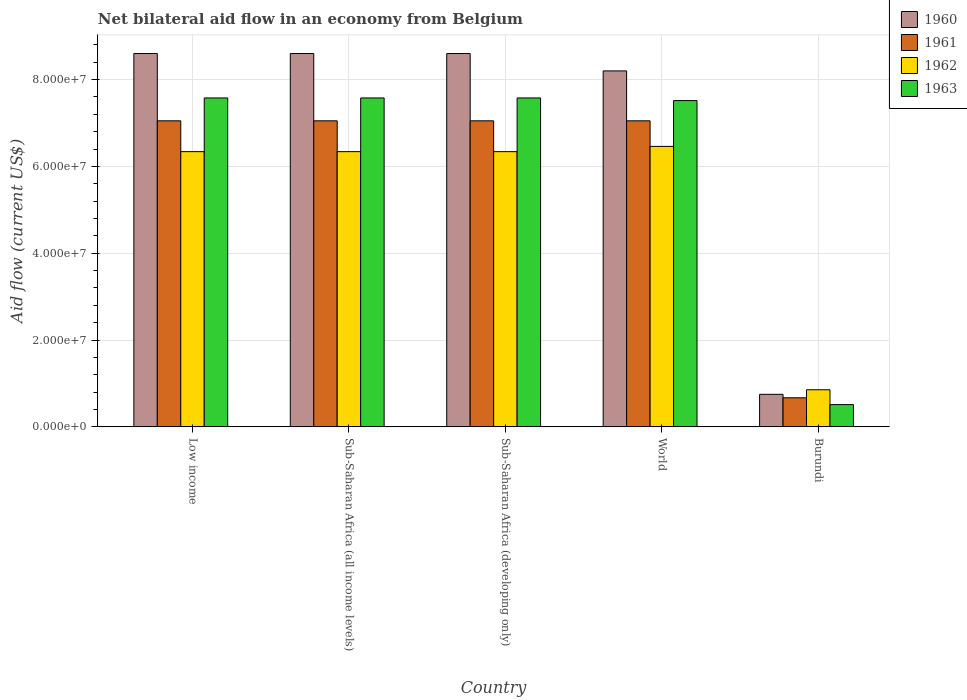How many groups of bars are there?
Keep it short and to the point. 5. Are the number of bars per tick equal to the number of legend labels?
Ensure brevity in your answer.  Yes. How many bars are there on the 1st tick from the left?
Provide a succinct answer. 4. What is the label of the 3rd group of bars from the left?
Your response must be concise. Sub-Saharan Africa (developing only). In how many cases, is the number of bars for a given country not equal to the number of legend labels?
Provide a short and direct response. 0. What is the net bilateral aid flow in 1962 in Burundi?
Offer a terse response. 8.55e+06. Across all countries, what is the maximum net bilateral aid flow in 1961?
Your response must be concise. 7.05e+07. Across all countries, what is the minimum net bilateral aid flow in 1961?
Your answer should be compact. 6.70e+06. In which country was the net bilateral aid flow in 1963 maximum?
Give a very brief answer. Low income. In which country was the net bilateral aid flow in 1960 minimum?
Your answer should be compact. Burundi. What is the total net bilateral aid flow in 1960 in the graph?
Make the answer very short. 3.48e+08. What is the difference between the net bilateral aid flow in 1960 in Sub-Saharan Africa (all income levels) and that in World?
Keep it short and to the point. 4.00e+06. What is the difference between the net bilateral aid flow in 1961 in Sub-Saharan Africa (all income levels) and the net bilateral aid flow in 1963 in World?
Your answer should be very brief. -4.66e+06. What is the average net bilateral aid flow in 1961 per country?
Ensure brevity in your answer.  5.77e+07. What is the difference between the net bilateral aid flow of/in 1962 and net bilateral aid flow of/in 1961 in Low income?
Give a very brief answer. -7.10e+06. In how many countries, is the net bilateral aid flow in 1962 greater than 24000000 US$?
Give a very brief answer. 4. What is the ratio of the net bilateral aid flow in 1960 in Low income to that in World?
Your response must be concise. 1.05. Is the net bilateral aid flow in 1962 in Burundi less than that in World?
Ensure brevity in your answer.  Yes. What is the difference between the highest and the second highest net bilateral aid flow in 1962?
Your answer should be very brief. 1.21e+06. What is the difference between the highest and the lowest net bilateral aid flow in 1961?
Your answer should be compact. 6.38e+07. In how many countries, is the net bilateral aid flow in 1962 greater than the average net bilateral aid flow in 1962 taken over all countries?
Your answer should be compact. 4. Is it the case that in every country, the sum of the net bilateral aid flow in 1960 and net bilateral aid flow in 1961 is greater than the sum of net bilateral aid flow in 1963 and net bilateral aid flow in 1962?
Keep it short and to the point. No. What does the 3rd bar from the left in Sub-Saharan Africa (developing only) represents?
Provide a short and direct response. 1962. Are all the bars in the graph horizontal?
Your answer should be very brief. No. How many countries are there in the graph?
Offer a very short reply. 5. Does the graph contain any zero values?
Provide a succinct answer. No. Does the graph contain grids?
Keep it short and to the point. Yes. How are the legend labels stacked?
Offer a very short reply. Vertical. What is the title of the graph?
Ensure brevity in your answer.  Net bilateral aid flow in an economy from Belgium. What is the label or title of the Y-axis?
Provide a short and direct response. Aid flow (current US$). What is the Aid flow (current US$) in 1960 in Low income?
Your answer should be compact. 8.60e+07. What is the Aid flow (current US$) of 1961 in Low income?
Your answer should be compact. 7.05e+07. What is the Aid flow (current US$) of 1962 in Low income?
Your answer should be very brief. 6.34e+07. What is the Aid flow (current US$) of 1963 in Low income?
Keep it short and to the point. 7.58e+07. What is the Aid flow (current US$) in 1960 in Sub-Saharan Africa (all income levels)?
Offer a very short reply. 8.60e+07. What is the Aid flow (current US$) in 1961 in Sub-Saharan Africa (all income levels)?
Ensure brevity in your answer.  7.05e+07. What is the Aid flow (current US$) of 1962 in Sub-Saharan Africa (all income levels)?
Provide a succinct answer. 6.34e+07. What is the Aid flow (current US$) of 1963 in Sub-Saharan Africa (all income levels)?
Provide a short and direct response. 7.58e+07. What is the Aid flow (current US$) in 1960 in Sub-Saharan Africa (developing only)?
Offer a terse response. 8.60e+07. What is the Aid flow (current US$) of 1961 in Sub-Saharan Africa (developing only)?
Ensure brevity in your answer.  7.05e+07. What is the Aid flow (current US$) in 1962 in Sub-Saharan Africa (developing only)?
Provide a short and direct response. 6.34e+07. What is the Aid flow (current US$) in 1963 in Sub-Saharan Africa (developing only)?
Your answer should be very brief. 7.58e+07. What is the Aid flow (current US$) of 1960 in World?
Make the answer very short. 8.20e+07. What is the Aid flow (current US$) of 1961 in World?
Make the answer very short. 7.05e+07. What is the Aid flow (current US$) in 1962 in World?
Make the answer very short. 6.46e+07. What is the Aid flow (current US$) of 1963 in World?
Provide a short and direct response. 7.52e+07. What is the Aid flow (current US$) of 1960 in Burundi?
Offer a very short reply. 7.50e+06. What is the Aid flow (current US$) of 1961 in Burundi?
Offer a terse response. 6.70e+06. What is the Aid flow (current US$) of 1962 in Burundi?
Offer a very short reply. 8.55e+06. What is the Aid flow (current US$) of 1963 in Burundi?
Your answer should be very brief. 5.13e+06. Across all countries, what is the maximum Aid flow (current US$) of 1960?
Your answer should be compact. 8.60e+07. Across all countries, what is the maximum Aid flow (current US$) of 1961?
Provide a short and direct response. 7.05e+07. Across all countries, what is the maximum Aid flow (current US$) in 1962?
Make the answer very short. 6.46e+07. Across all countries, what is the maximum Aid flow (current US$) in 1963?
Offer a terse response. 7.58e+07. Across all countries, what is the minimum Aid flow (current US$) in 1960?
Provide a succinct answer. 7.50e+06. Across all countries, what is the minimum Aid flow (current US$) of 1961?
Provide a succinct answer. 6.70e+06. Across all countries, what is the minimum Aid flow (current US$) of 1962?
Provide a succinct answer. 8.55e+06. Across all countries, what is the minimum Aid flow (current US$) of 1963?
Give a very brief answer. 5.13e+06. What is the total Aid flow (current US$) of 1960 in the graph?
Give a very brief answer. 3.48e+08. What is the total Aid flow (current US$) in 1961 in the graph?
Your answer should be compact. 2.89e+08. What is the total Aid flow (current US$) of 1962 in the graph?
Give a very brief answer. 2.63e+08. What is the total Aid flow (current US$) in 1963 in the graph?
Offer a very short reply. 3.08e+08. What is the difference between the Aid flow (current US$) of 1961 in Low income and that in Sub-Saharan Africa (all income levels)?
Your response must be concise. 0. What is the difference between the Aid flow (current US$) in 1962 in Low income and that in Sub-Saharan Africa (all income levels)?
Provide a short and direct response. 0. What is the difference between the Aid flow (current US$) of 1962 in Low income and that in World?
Make the answer very short. -1.21e+06. What is the difference between the Aid flow (current US$) in 1960 in Low income and that in Burundi?
Provide a succinct answer. 7.85e+07. What is the difference between the Aid flow (current US$) in 1961 in Low income and that in Burundi?
Your answer should be compact. 6.38e+07. What is the difference between the Aid flow (current US$) of 1962 in Low income and that in Burundi?
Offer a very short reply. 5.48e+07. What is the difference between the Aid flow (current US$) of 1963 in Low income and that in Burundi?
Provide a short and direct response. 7.06e+07. What is the difference between the Aid flow (current US$) in 1960 in Sub-Saharan Africa (all income levels) and that in World?
Your response must be concise. 4.00e+06. What is the difference between the Aid flow (current US$) in 1962 in Sub-Saharan Africa (all income levels) and that in World?
Your answer should be compact. -1.21e+06. What is the difference between the Aid flow (current US$) of 1960 in Sub-Saharan Africa (all income levels) and that in Burundi?
Provide a succinct answer. 7.85e+07. What is the difference between the Aid flow (current US$) of 1961 in Sub-Saharan Africa (all income levels) and that in Burundi?
Your answer should be compact. 6.38e+07. What is the difference between the Aid flow (current US$) in 1962 in Sub-Saharan Africa (all income levels) and that in Burundi?
Your answer should be compact. 5.48e+07. What is the difference between the Aid flow (current US$) in 1963 in Sub-Saharan Africa (all income levels) and that in Burundi?
Your answer should be very brief. 7.06e+07. What is the difference between the Aid flow (current US$) of 1961 in Sub-Saharan Africa (developing only) and that in World?
Your answer should be compact. 0. What is the difference between the Aid flow (current US$) in 1962 in Sub-Saharan Africa (developing only) and that in World?
Your answer should be very brief. -1.21e+06. What is the difference between the Aid flow (current US$) of 1963 in Sub-Saharan Africa (developing only) and that in World?
Give a very brief answer. 6.10e+05. What is the difference between the Aid flow (current US$) of 1960 in Sub-Saharan Africa (developing only) and that in Burundi?
Keep it short and to the point. 7.85e+07. What is the difference between the Aid flow (current US$) of 1961 in Sub-Saharan Africa (developing only) and that in Burundi?
Make the answer very short. 6.38e+07. What is the difference between the Aid flow (current US$) in 1962 in Sub-Saharan Africa (developing only) and that in Burundi?
Provide a succinct answer. 5.48e+07. What is the difference between the Aid flow (current US$) in 1963 in Sub-Saharan Africa (developing only) and that in Burundi?
Your response must be concise. 7.06e+07. What is the difference between the Aid flow (current US$) of 1960 in World and that in Burundi?
Your answer should be very brief. 7.45e+07. What is the difference between the Aid flow (current US$) of 1961 in World and that in Burundi?
Offer a very short reply. 6.38e+07. What is the difference between the Aid flow (current US$) of 1962 in World and that in Burundi?
Your answer should be compact. 5.61e+07. What is the difference between the Aid flow (current US$) in 1963 in World and that in Burundi?
Ensure brevity in your answer.  7.00e+07. What is the difference between the Aid flow (current US$) in 1960 in Low income and the Aid flow (current US$) in 1961 in Sub-Saharan Africa (all income levels)?
Keep it short and to the point. 1.55e+07. What is the difference between the Aid flow (current US$) in 1960 in Low income and the Aid flow (current US$) in 1962 in Sub-Saharan Africa (all income levels)?
Provide a short and direct response. 2.26e+07. What is the difference between the Aid flow (current US$) in 1960 in Low income and the Aid flow (current US$) in 1963 in Sub-Saharan Africa (all income levels)?
Provide a succinct answer. 1.02e+07. What is the difference between the Aid flow (current US$) in 1961 in Low income and the Aid flow (current US$) in 1962 in Sub-Saharan Africa (all income levels)?
Provide a succinct answer. 7.10e+06. What is the difference between the Aid flow (current US$) of 1961 in Low income and the Aid flow (current US$) of 1963 in Sub-Saharan Africa (all income levels)?
Offer a very short reply. -5.27e+06. What is the difference between the Aid flow (current US$) in 1962 in Low income and the Aid flow (current US$) in 1963 in Sub-Saharan Africa (all income levels)?
Offer a terse response. -1.24e+07. What is the difference between the Aid flow (current US$) of 1960 in Low income and the Aid flow (current US$) of 1961 in Sub-Saharan Africa (developing only)?
Your answer should be compact. 1.55e+07. What is the difference between the Aid flow (current US$) in 1960 in Low income and the Aid flow (current US$) in 1962 in Sub-Saharan Africa (developing only)?
Your answer should be compact. 2.26e+07. What is the difference between the Aid flow (current US$) in 1960 in Low income and the Aid flow (current US$) in 1963 in Sub-Saharan Africa (developing only)?
Keep it short and to the point. 1.02e+07. What is the difference between the Aid flow (current US$) in 1961 in Low income and the Aid flow (current US$) in 1962 in Sub-Saharan Africa (developing only)?
Ensure brevity in your answer.  7.10e+06. What is the difference between the Aid flow (current US$) of 1961 in Low income and the Aid flow (current US$) of 1963 in Sub-Saharan Africa (developing only)?
Offer a terse response. -5.27e+06. What is the difference between the Aid flow (current US$) in 1962 in Low income and the Aid flow (current US$) in 1963 in Sub-Saharan Africa (developing only)?
Provide a short and direct response. -1.24e+07. What is the difference between the Aid flow (current US$) in 1960 in Low income and the Aid flow (current US$) in 1961 in World?
Your response must be concise. 1.55e+07. What is the difference between the Aid flow (current US$) in 1960 in Low income and the Aid flow (current US$) in 1962 in World?
Offer a terse response. 2.14e+07. What is the difference between the Aid flow (current US$) of 1960 in Low income and the Aid flow (current US$) of 1963 in World?
Keep it short and to the point. 1.08e+07. What is the difference between the Aid flow (current US$) in 1961 in Low income and the Aid flow (current US$) in 1962 in World?
Your answer should be very brief. 5.89e+06. What is the difference between the Aid flow (current US$) of 1961 in Low income and the Aid flow (current US$) of 1963 in World?
Provide a succinct answer. -4.66e+06. What is the difference between the Aid flow (current US$) of 1962 in Low income and the Aid flow (current US$) of 1963 in World?
Offer a terse response. -1.18e+07. What is the difference between the Aid flow (current US$) of 1960 in Low income and the Aid flow (current US$) of 1961 in Burundi?
Your answer should be compact. 7.93e+07. What is the difference between the Aid flow (current US$) of 1960 in Low income and the Aid flow (current US$) of 1962 in Burundi?
Keep it short and to the point. 7.74e+07. What is the difference between the Aid flow (current US$) of 1960 in Low income and the Aid flow (current US$) of 1963 in Burundi?
Offer a terse response. 8.09e+07. What is the difference between the Aid flow (current US$) in 1961 in Low income and the Aid flow (current US$) in 1962 in Burundi?
Offer a very short reply. 6.20e+07. What is the difference between the Aid flow (current US$) in 1961 in Low income and the Aid flow (current US$) in 1963 in Burundi?
Offer a very short reply. 6.54e+07. What is the difference between the Aid flow (current US$) in 1962 in Low income and the Aid flow (current US$) in 1963 in Burundi?
Provide a short and direct response. 5.83e+07. What is the difference between the Aid flow (current US$) of 1960 in Sub-Saharan Africa (all income levels) and the Aid flow (current US$) of 1961 in Sub-Saharan Africa (developing only)?
Your response must be concise. 1.55e+07. What is the difference between the Aid flow (current US$) of 1960 in Sub-Saharan Africa (all income levels) and the Aid flow (current US$) of 1962 in Sub-Saharan Africa (developing only)?
Give a very brief answer. 2.26e+07. What is the difference between the Aid flow (current US$) of 1960 in Sub-Saharan Africa (all income levels) and the Aid flow (current US$) of 1963 in Sub-Saharan Africa (developing only)?
Provide a short and direct response. 1.02e+07. What is the difference between the Aid flow (current US$) of 1961 in Sub-Saharan Africa (all income levels) and the Aid flow (current US$) of 1962 in Sub-Saharan Africa (developing only)?
Provide a succinct answer. 7.10e+06. What is the difference between the Aid flow (current US$) in 1961 in Sub-Saharan Africa (all income levels) and the Aid flow (current US$) in 1963 in Sub-Saharan Africa (developing only)?
Your response must be concise. -5.27e+06. What is the difference between the Aid flow (current US$) in 1962 in Sub-Saharan Africa (all income levels) and the Aid flow (current US$) in 1963 in Sub-Saharan Africa (developing only)?
Provide a short and direct response. -1.24e+07. What is the difference between the Aid flow (current US$) in 1960 in Sub-Saharan Africa (all income levels) and the Aid flow (current US$) in 1961 in World?
Ensure brevity in your answer.  1.55e+07. What is the difference between the Aid flow (current US$) of 1960 in Sub-Saharan Africa (all income levels) and the Aid flow (current US$) of 1962 in World?
Keep it short and to the point. 2.14e+07. What is the difference between the Aid flow (current US$) in 1960 in Sub-Saharan Africa (all income levels) and the Aid flow (current US$) in 1963 in World?
Your response must be concise. 1.08e+07. What is the difference between the Aid flow (current US$) of 1961 in Sub-Saharan Africa (all income levels) and the Aid flow (current US$) of 1962 in World?
Your answer should be very brief. 5.89e+06. What is the difference between the Aid flow (current US$) in 1961 in Sub-Saharan Africa (all income levels) and the Aid flow (current US$) in 1963 in World?
Ensure brevity in your answer.  -4.66e+06. What is the difference between the Aid flow (current US$) in 1962 in Sub-Saharan Africa (all income levels) and the Aid flow (current US$) in 1963 in World?
Give a very brief answer. -1.18e+07. What is the difference between the Aid flow (current US$) of 1960 in Sub-Saharan Africa (all income levels) and the Aid flow (current US$) of 1961 in Burundi?
Your answer should be very brief. 7.93e+07. What is the difference between the Aid flow (current US$) in 1960 in Sub-Saharan Africa (all income levels) and the Aid flow (current US$) in 1962 in Burundi?
Keep it short and to the point. 7.74e+07. What is the difference between the Aid flow (current US$) in 1960 in Sub-Saharan Africa (all income levels) and the Aid flow (current US$) in 1963 in Burundi?
Provide a succinct answer. 8.09e+07. What is the difference between the Aid flow (current US$) of 1961 in Sub-Saharan Africa (all income levels) and the Aid flow (current US$) of 1962 in Burundi?
Provide a short and direct response. 6.20e+07. What is the difference between the Aid flow (current US$) in 1961 in Sub-Saharan Africa (all income levels) and the Aid flow (current US$) in 1963 in Burundi?
Offer a very short reply. 6.54e+07. What is the difference between the Aid flow (current US$) in 1962 in Sub-Saharan Africa (all income levels) and the Aid flow (current US$) in 1963 in Burundi?
Provide a succinct answer. 5.83e+07. What is the difference between the Aid flow (current US$) of 1960 in Sub-Saharan Africa (developing only) and the Aid flow (current US$) of 1961 in World?
Your answer should be very brief. 1.55e+07. What is the difference between the Aid flow (current US$) in 1960 in Sub-Saharan Africa (developing only) and the Aid flow (current US$) in 1962 in World?
Provide a short and direct response. 2.14e+07. What is the difference between the Aid flow (current US$) in 1960 in Sub-Saharan Africa (developing only) and the Aid flow (current US$) in 1963 in World?
Your answer should be compact. 1.08e+07. What is the difference between the Aid flow (current US$) in 1961 in Sub-Saharan Africa (developing only) and the Aid flow (current US$) in 1962 in World?
Make the answer very short. 5.89e+06. What is the difference between the Aid flow (current US$) of 1961 in Sub-Saharan Africa (developing only) and the Aid flow (current US$) of 1963 in World?
Offer a very short reply. -4.66e+06. What is the difference between the Aid flow (current US$) of 1962 in Sub-Saharan Africa (developing only) and the Aid flow (current US$) of 1963 in World?
Make the answer very short. -1.18e+07. What is the difference between the Aid flow (current US$) of 1960 in Sub-Saharan Africa (developing only) and the Aid flow (current US$) of 1961 in Burundi?
Offer a terse response. 7.93e+07. What is the difference between the Aid flow (current US$) in 1960 in Sub-Saharan Africa (developing only) and the Aid flow (current US$) in 1962 in Burundi?
Your response must be concise. 7.74e+07. What is the difference between the Aid flow (current US$) of 1960 in Sub-Saharan Africa (developing only) and the Aid flow (current US$) of 1963 in Burundi?
Keep it short and to the point. 8.09e+07. What is the difference between the Aid flow (current US$) in 1961 in Sub-Saharan Africa (developing only) and the Aid flow (current US$) in 1962 in Burundi?
Keep it short and to the point. 6.20e+07. What is the difference between the Aid flow (current US$) in 1961 in Sub-Saharan Africa (developing only) and the Aid flow (current US$) in 1963 in Burundi?
Provide a short and direct response. 6.54e+07. What is the difference between the Aid flow (current US$) in 1962 in Sub-Saharan Africa (developing only) and the Aid flow (current US$) in 1963 in Burundi?
Your answer should be compact. 5.83e+07. What is the difference between the Aid flow (current US$) of 1960 in World and the Aid flow (current US$) of 1961 in Burundi?
Your response must be concise. 7.53e+07. What is the difference between the Aid flow (current US$) of 1960 in World and the Aid flow (current US$) of 1962 in Burundi?
Your answer should be very brief. 7.34e+07. What is the difference between the Aid flow (current US$) of 1960 in World and the Aid flow (current US$) of 1963 in Burundi?
Provide a short and direct response. 7.69e+07. What is the difference between the Aid flow (current US$) of 1961 in World and the Aid flow (current US$) of 1962 in Burundi?
Provide a succinct answer. 6.20e+07. What is the difference between the Aid flow (current US$) in 1961 in World and the Aid flow (current US$) in 1963 in Burundi?
Provide a succinct answer. 6.54e+07. What is the difference between the Aid flow (current US$) of 1962 in World and the Aid flow (current US$) of 1963 in Burundi?
Offer a terse response. 5.95e+07. What is the average Aid flow (current US$) of 1960 per country?
Keep it short and to the point. 6.95e+07. What is the average Aid flow (current US$) of 1961 per country?
Ensure brevity in your answer.  5.77e+07. What is the average Aid flow (current US$) of 1962 per country?
Ensure brevity in your answer.  5.27e+07. What is the average Aid flow (current US$) in 1963 per country?
Give a very brief answer. 6.15e+07. What is the difference between the Aid flow (current US$) in 1960 and Aid flow (current US$) in 1961 in Low income?
Your answer should be very brief. 1.55e+07. What is the difference between the Aid flow (current US$) of 1960 and Aid flow (current US$) of 1962 in Low income?
Offer a terse response. 2.26e+07. What is the difference between the Aid flow (current US$) in 1960 and Aid flow (current US$) in 1963 in Low income?
Keep it short and to the point. 1.02e+07. What is the difference between the Aid flow (current US$) in 1961 and Aid flow (current US$) in 1962 in Low income?
Ensure brevity in your answer.  7.10e+06. What is the difference between the Aid flow (current US$) in 1961 and Aid flow (current US$) in 1963 in Low income?
Your answer should be very brief. -5.27e+06. What is the difference between the Aid flow (current US$) of 1962 and Aid flow (current US$) of 1963 in Low income?
Keep it short and to the point. -1.24e+07. What is the difference between the Aid flow (current US$) in 1960 and Aid flow (current US$) in 1961 in Sub-Saharan Africa (all income levels)?
Your answer should be very brief. 1.55e+07. What is the difference between the Aid flow (current US$) of 1960 and Aid flow (current US$) of 1962 in Sub-Saharan Africa (all income levels)?
Your answer should be compact. 2.26e+07. What is the difference between the Aid flow (current US$) in 1960 and Aid flow (current US$) in 1963 in Sub-Saharan Africa (all income levels)?
Keep it short and to the point. 1.02e+07. What is the difference between the Aid flow (current US$) of 1961 and Aid flow (current US$) of 1962 in Sub-Saharan Africa (all income levels)?
Offer a very short reply. 7.10e+06. What is the difference between the Aid flow (current US$) in 1961 and Aid flow (current US$) in 1963 in Sub-Saharan Africa (all income levels)?
Make the answer very short. -5.27e+06. What is the difference between the Aid flow (current US$) in 1962 and Aid flow (current US$) in 1963 in Sub-Saharan Africa (all income levels)?
Your answer should be very brief. -1.24e+07. What is the difference between the Aid flow (current US$) of 1960 and Aid flow (current US$) of 1961 in Sub-Saharan Africa (developing only)?
Your answer should be compact. 1.55e+07. What is the difference between the Aid flow (current US$) in 1960 and Aid flow (current US$) in 1962 in Sub-Saharan Africa (developing only)?
Offer a terse response. 2.26e+07. What is the difference between the Aid flow (current US$) in 1960 and Aid flow (current US$) in 1963 in Sub-Saharan Africa (developing only)?
Your answer should be very brief. 1.02e+07. What is the difference between the Aid flow (current US$) of 1961 and Aid flow (current US$) of 1962 in Sub-Saharan Africa (developing only)?
Keep it short and to the point. 7.10e+06. What is the difference between the Aid flow (current US$) of 1961 and Aid flow (current US$) of 1963 in Sub-Saharan Africa (developing only)?
Offer a very short reply. -5.27e+06. What is the difference between the Aid flow (current US$) in 1962 and Aid flow (current US$) in 1963 in Sub-Saharan Africa (developing only)?
Give a very brief answer. -1.24e+07. What is the difference between the Aid flow (current US$) in 1960 and Aid flow (current US$) in 1961 in World?
Your answer should be compact. 1.15e+07. What is the difference between the Aid flow (current US$) in 1960 and Aid flow (current US$) in 1962 in World?
Your answer should be compact. 1.74e+07. What is the difference between the Aid flow (current US$) of 1960 and Aid flow (current US$) of 1963 in World?
Provide a short and direct response. 6.84e+06. What is the difference between the Aid flow (current US$) in 1961 and Aid flow (current US$) in 1962 in World?
Keep it short and to the point. 5.89e+06. What is the difference between the Aid flow (current US$) in 1961 and Aid flow (current US$) in 1963 in World?
Provide a succinct answer. -4.66e+06. What is the difference between the Aid flow (current US$) of 1962 and Aid flow (current US$) of 1963 in World?
Give a very brief answer. -1.06e+07. What is the difference between the Aid flow (current US$) of 1960 and Aid flow (current US$) of 1962 in Burundi?
Your answer should be compact. -1.05e+06. What is the difference between the Aid flow (current US$) of 1960 and Aid flow (current US$) of 1963 in Burundi?
Offer a terse response. 2.37e+06. What is the difference between the Aid flow (current US$) in 1961 and Aid flow (current US$) in 1962 in Burundi?
Give a very brief answer. -1.85e+06. What is the difference between the Aid flow (current US$) in 1961 and Aid flow (current US$) in 1963 in Burundi?
Give a very brief answer. 1.57e+06. What is the difference between the Aid flow (current US$) of 1962 and Aid flow (current US$) of 1963 in Burundi?
Keep it short and to the point. 3.42e+06. What is the ratio of the Aid flow (current US$) in 1960 in Low income to that in Sub-Saharan Africa (all income levels)?
Your answer should be very brief. 1. What is the ratio of the Aid flow (current US$) of 1961 in Low income to that in Sub-Saharan Africa (all income levels)?
Provide a short and direct response. 1. What is the ratio of the Aid flow (current US$) in 1963 in Low income to that in Sub-Saharan Africa (all income levels)?
Make the answer very short. 1. What is the ratio of the Aid flow (current US$) in 1960 in Low income to that in Sub-Saharan Africa (developing only)?
Make the answer very short. 1. What is the ratio of the Aid flow (current US$) in 1960 in Low income to that in World?
Your answer should be very brief. 1.05. What is the ratio of the Aid flow (current US$) in 1962 in Low income to that in World?
Your answer should be compact. 0.98. What is the ratio of the Aid flow (current US$) in 1963 in Low income to that in World?
Provide a succinct answer. 1.01. What is the ratio of the Aid flow (current US$) in 1960 in Low income to that in Burundi?
Provide a succinct answer. 11.47. What is the ratio of the Aid flow (current US$) in 1961 in Low income to that in Burundi?
Provide a short and direct response. 10.52. What is the ratio of the Aid flow (current US$) in 1962 in Low income to that in Burundi?
Your answer should be very brief. 7.42. What is the ratio of the Aid flow (current US$) of 1963 in Low income to that in Burundi?
Offer a terse response. 14.77. What is the ratio of the Aid flow (current US$) of 1960 in Sub-Saharan Africa (all income levels) to that in Sub-Saharan Africa (developing only)?
Ensure brevity in your answer.  1. What is the ratio of the Aid flow (current US$) of 1961 in Sub-Saharan Africa (all income levels) to that in Sub-Saharan Africa (developing only)?
Offer a terse response. 1. What is the ratio of the Aid flow (current US$) of 1960 in Sub-Saharan Africa (all income levels) to that in World?
Your response must be concise. 1.05. What is the ratio of the Aid flow (current US$) of 1962 in Sub-Saharan Africa (all income levels) to that in World?
Your answer should be very brief. 0.98. What is the ratio of the Aid flow (current US$) in 1963 in Sub-Saharan Africa (all income levels) to that in World?
Keep it short and to the point. 1.01. What is the ratio of the Aid flow (current US$) of 1960 in Sub-Saharan Africa (all income levels) to that in Burundi?
Keep it short and to the point. 11.47. What is the ratio of the Aid flow (current US$) in 1961 in Sub-Saharan Africa (all income levels) to that in Burundi?
Provide a short and direct response. 10.52. What is the ratio of the Aid flow (current US$) of 1962 in Sub-Saharan Africa (all income levels) to that in Burundi?
Your answer should be compact. 7.42. What is the ratio of the Aid flow (current US$) of 1963 in Sub-Saharan Africa (all income levels) to that in Burundi?
Ensure brevity in your answer.  14.77. What is the ratio of the Aid flow (current US$) of 1960 in Sub-Saharan Africa (developing only) to that in World?
Your response must be concise. 1.05. What is the ratio of the Aid flow (current US$) in 1961 in Sub-Saharan Africa (developing only) to that in World?
Provide a short and direct response. 1. What is the ratio of the Aid flow (current US$) of 1962 in Sub-Saharan Africa (developing only) to that in World?
Keep it short and to the point. 0.98. What is the ratio of the Aid flow (current US$) of 1963 in Sub-Saharan Africa (developing only) to that in World?
Keep it short and to the point. 1.01. What is the ratio of the Aid flow (current US$) of 1960 in Sub-Saharan Africa (developing only) to that in Burundi?
Ensure brevity in your answer.  11.47. What is the ratio of the Aid flow (current US$) of 1961 in Sub-Saharan Africa (developing only) to that in Burundi?
Offer a terse response. 10.52. What is the ratio of the Aid flow (current US$) in 1962 in Sub-Saharan Africa (developing only) to that in Burundi?
Your answer should be compact. 7.42. What is the ratio of the Aid flow (current US$) of 1963 in Sub-Saharan Africa (developing only) to that in Burundi?
Provide a short and direct response. 14.77. What is the ratio of the Aid flow (current US$) in 1960 in World to that in Burundi?
Your answer should be very brief. 10.93. What is the ratio of the Aid flow (current US$) of 1961 in World to that in Burundi?
Provide a short and direct response. 10.52. What is the ratio of the Aid flow (current US$) in 1962 in World to that in Burundi?
Give a very brief answer. 7.56. What is the ratio of the Aid flow (current US$) in 1963 in World to that in Burundi?
Offer a terse response. 14.65. What is the difference between the highest and the second highest Aid flow (current US$) in 1960?
Your answer should be compact. 0. What is the difference between the highest and the second highest Aid flow (current US$) in 1961?
Ensure brevity in your answer.  0. What is the difference between the highest and the second highest Aid flow (current US$) of 1962?
Keep it short and to the point. 1.21e+06. What is the difference between the highest and the lowest Aid flow (current US$) in 1960?
Ensure brevity in your answer.  7.85e+07. What is the difference between the highest and the lowest Aid flow (current US$) in 1961?
Your answer should be compact. 6.38e+07. What is the difference between the highest and the lowest Aid flow (current US$) in 1962?
Give a very brief answer. 5.61e+07. What is the difference between the highest and the lowest Aid flow (current US$) in 1963?
Keep it short and to the point. 7.06e+07. 